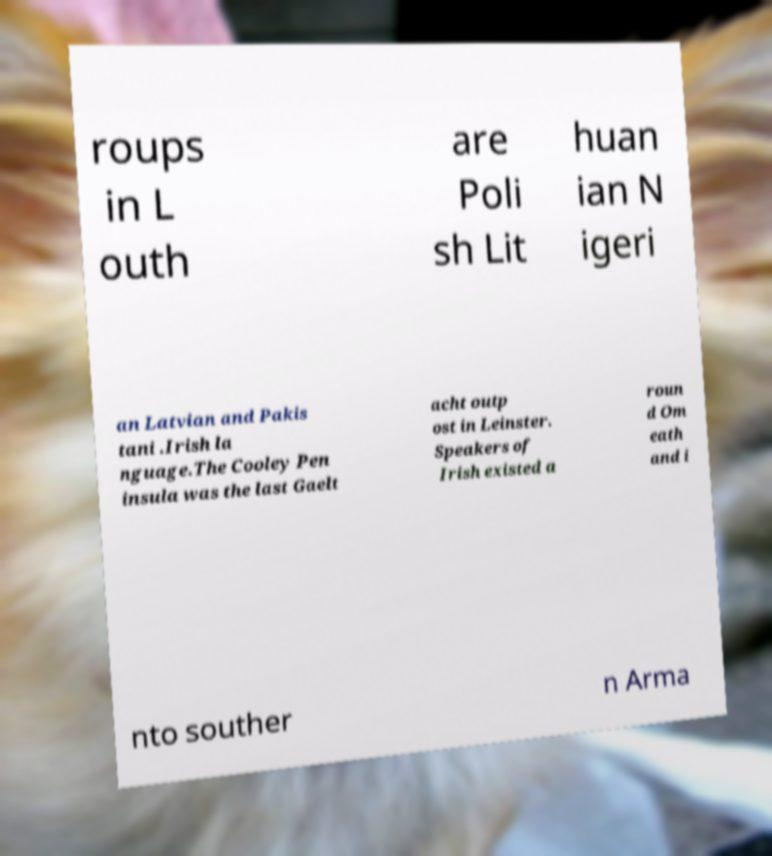For documentation purposes, I need the text within this image transcribed. Could you provide that? roups in L outh are Poli sh Lit huan ian N igeri an Latvian and Pakis tani .Irish la nguage.The Cooley Pen insula was the last Gaelt acht outp ost in Leinster. Speakers of Irish existed a roun d Om eath and i nto souther n Arma 